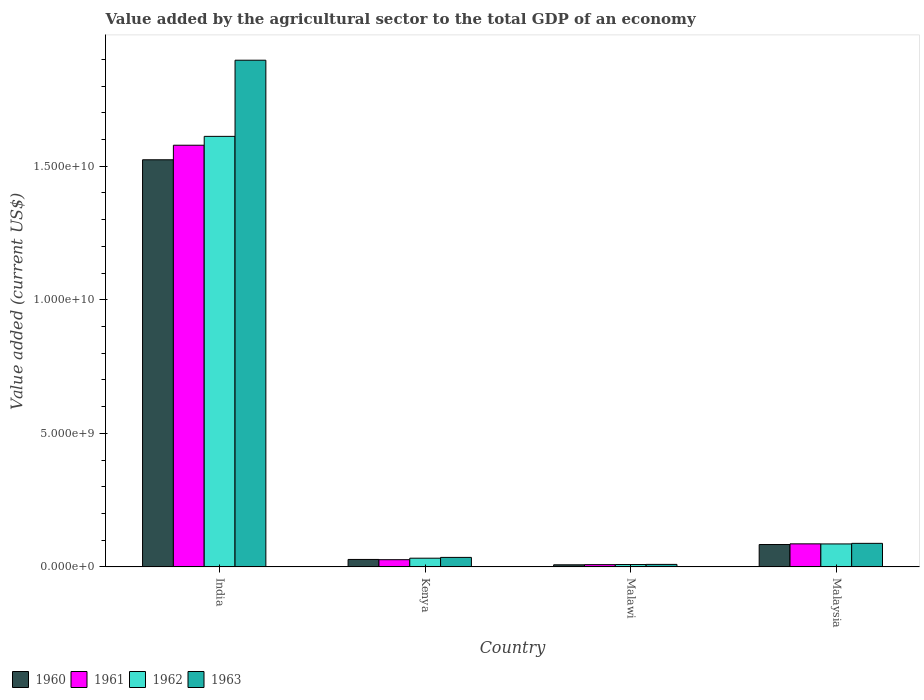Are the number of bars per tick equal to the number of legend labels?
Your answer should be very brief. Yes. Are the number of bars on each tick of the X-axis equal?
Offer a very short reply. Yes. How many bars are there on the 1st tick from the left?
Give a very brief answer. 4. How many bars are there on the 4th tick from the right?
Keep it short and to the point. 4. In how many cases, is the number of bars for a given country not equal to the number of legend labels?
Your answer should be compact. 0. What is the value added by the agricultural sector to the total GDP in 1963 in Malaysia?
Make the answer very short. 8.82e+08. Across all countries, what is the maximum value added by the agricultural sector to the total GDP in 1963?
Make the answer very short. 1.90e+1. Across all countries, what is the minimum value added by the agricultural sector to the total GDP in 1962?
Make the answer very short. 8.90e+07. In which country was the value added by the agricultural sector to the total GDP in 1960 minimum?
Offer a very short reply. Malawi. What is the total value added by the agricultural sector to the total GDP in 1963 in the graph?
Ensure brevity in your answer.  2.03e+1. What is the difference between the value added by the agricultural sector to the total GDP in 1960 in India and that in Malaysia?
Give a very brief answer. 1.44e+1. What is the difference between the value added by the agricultural sector to the total GDP in 1963 in Malaysia and the value added by the agricultural sector to the total GDP in 1962 in Malawi?
Your answer should be compact. 7.93e+08. What is the average value added by the agricultural sector to the total GDP in 1961 per country?
Offer a terse response. 4.25e+09. What is the difference between the value added by the agricultural sector to the total GDP of/in 1963 and value added by the agricultural sector to the total GDP of/in 1962 in India?
Your answer should be very brief. 2.85e+09. What is the ratio of the value added by the agricultural sector to the total GDP in 1962 in India to that in Malawi?
Provide a succinct answer. 180.99. Is the value added by the agricultural sector to the total GDP in 1963 in India less than that in Kenya?
Provide a short and direct response. No. What is the difference between the highest and the second highest value added by the agricultural sector to the total GDP in 1960?
Give a very brief answer. -5.58e+08. What is the difference between the highest and the lowest value added by the agricultural sector to the total GDP in 1962?
Your answer should be very brief. 1.60e+1. Is it the case that in every country, the sum of the value added by the agricultural sector to the total GDP in 1961 and value added by the agricultural sector to the total GDP in 1960 is greater than the sum of value added by the agricultural sector to the total GDP in 1963 and value added by the agricultural sector to the total GDP in 1962?
Give a very brief answer. No. What does the 1st bar from the left in Kenya represents?
Offer a very short reply. 1960. What does the 4th bar from the right in Kenya represents?
Ensure brevity in your answer.  1960. How many bars are there?
Your answer should be compact. 16. Are all the bars in the graph horizontal?
Provide a short and direct response. No. How many countries are there in the graph?
Give a very brief answer. 4. Does the graph contain any zero values?
Offer a very short reply. No. Does the graph contain grids?
Provide a succinct answer. No. Where does the legend appear in the graph?
Provide a succinct answer. Bottom left. How are the legend labels stacked?
Your answer should be compact. Horizontal. What is the title of the graph?
Make the answer very short. Value added by the agricultural sector to the total GDP of an economy. Does "1997" appear as one of the legend labels in the graph?
Ensure brevity in your answer.  No. What is the label or title of the X-axis?
Keep it short and to the point. Country. What is the label or title of the Y-axis?
Give a very brief answer. Value added (current US$). What is the Value added (current US$) in 1960 in India?
Provide a short and direct response. 1.52e+1. What is the Value added (current US$) in 1961 in India?
Your answer should be compact. 1.58e+1. What is the Value added (current US$) of 1962 in India?
Offer a very short reply. 1.61e+1. What is the Value added (current US$) of 1963 in India?
Make the answer very short. 1.90e+1. What is the Value added (current US$) of 1960 in Kenya?
Provide a succinct answer. 2.80e+08. What is the Value added (current US$) of 1961 in Kenya?
Offer a terse response. 2.70e+08. What is the Value added (current US$) of 1962 in Kenya?
Keep it short and to the point. 3.26e+08. What is the Value added (current US$) of 1963 in Kenya?
Ensure brevity in your answer.  3.56e+08. What is the Value added (current US$) in 1960 in Malawi?
Make the answer very short. 7.88e+07. What is the Value added (current US$) of 1961 in Malawi?
Provide a short and direct response. 8.48e+07. What is the Value added (current US$) of 1962 in Malawi?
Make the answer very short. 8.90e+07. What is the Value added (current US$) in 1963 in Malawi?
Provide a succinct answer. 9.39e+07. What is the Value added (current US$) of 1960 in Malaysia?
Give a very brief answer. 8.38e+08. What is the Value added (current US$) in 1961 in Malaysia?
Your response must be concise. 8.63e+08. What is the Value added (current US$) of 1962 in Malaysia?
Your response must be concise. 8.60e+08. What is the Value added (current US$) of 1963 in Malaysia?
Provide a short and direct response. 8.82e+08. Across all countries, what is the maximum Value added (current US$) of 1960?
Make the answer very short. 1.52e+1. Across all countries, what is the maximum Value added (current US$) in 1961?
Provide a short and direct response. 1.58e+1. Across all countries, what is the maximum Value added (current US$) of 1962?
Keep it short and to the point. 1.61e+1. Across all countries, what is the maximum Value added (current US$) in 1963?
Your response must be concise. 1.90e+1. Across all countries, what is the minimum Value added (current US$) in 1960?
Provide a short and direct response. 7.88e+07. Across all countries, what is the minimum Value added (current US$) of 1961?
Your response must be concise. 8.48e+07. Across all countries, what is the minimum Value added (current US$) in 1962?
Ensure brevity in your answer.  8.90e+07. Across all countries, what is the minimum Value added (current US$) of 1963?
Provide a short and direct response. 9.39e+07. What is the total Value added (current US$) of 1960 in the graph?
Offer a very short reply. 1.64e+1. What is the total Value added (current US$) of 1961 in the graph?
Offer a terse response. 1.70e+1. What is the total Value added (current US$) in 1962 in the graph?
Give a very brief answer. 1.74e+1. What is the total Value added (current US$) of 1963 in the graph?
Keep it short and to the point. 2.03e+1. What is the difference between the Value added (current US$) of 1960 in India and that in Kenya?
Your response must be concise. 1.50e+1. What is the difference between the Value added (current US$) in 1961 in India and that in Kenya?
Ensure brevity in your answer.  1.55e+1. What is the difference between the Value added (current US$) of 1962 in India and that in Kenya?
Offer a very short reply. 1.58e+1. What is the difference between the Value added (current US$) in 1963 in India and that in Kenya?
Your response must be concise. 1.86e+1. What is the difference between the Value added (current US$) in 1960 in India and that in Malawi?
Ensure brevity in your answer.  1.52e+1. What is the difference between the Value added (current US$) of 1961 in India and that in Malawi?
Give a very brief answer. 1.57e+1. What is the difference between the Value added (current US$) in 1962 in India and that in Malawi?
Your answer should be compact. 1.60e+1. What is the difference between the Value added (current US$) in 1963 in India and that in Malawi?
Your answer should be compact. 1.89e+1. What is the difference between the Value added (current US$) in 1960 in India and that in Malaysia?
Your answer should be compact. 1.44e+1. What is the difference between the Value added (current US$) in 1961 in India and that in Malaysia?
Your response must be concise. 1.49e+1. What is the difference between the Value added (current US$) of 1962 in India and that in Malaysia?
Keep it short and to the point. 1.53e+1. What is the difference between the Value added (current US$) of 1963 in India and that in Malaysia?
Keep it short and to the point. 1.81e+1. What is the difference between the Value added (current US$) of 1960 in Kenya and that in Malawi?
Keep it short and to the point. 2.01e+08. What is the difference between the Value added (current US$) of 1961 in Kenya and that in Malawi?
Your response must be concise. 1.85e+08. What is the difference between the Value added (current US$) in 1962 in Kenya and that in Malawi?
Your answer should be very brief. 2.37e+08. What is the difference between the Value added (current US$) in 1963 in Kenya and that in Malawi?
Your answer should be compact. 2.62e+08. What is the difference between the Value added (current US$) in 1960 in Kenya and that in Malaysia?
Provide a succinct answer. -5.58e+08. What is the difference between the Value added (current US$) of 1961 in Kenya and that in Malaysia?
Your response must be concise. -5.93e+08. What is the difference between the Value added (current US$) of 1962 in Kenya and that in Malaysia?
Keep it short and to the point. -5.34e+08. What is the difference between the Value added (current US$) in 1963 in Kenya and that in Malaysia?
Your answer should be compact. -5.25e+08. What is the difference between the Value added (current US$) of 1960 in Malawi and that in Malaysia?
Make the answer very short. -7.59e+08. What is the difference between the Value added (current US$) of 1961 in Malawi and that in Malaysia?
Give a very brief answer. -7.78e+08. What is the difference between the Value added (current US$) of 1962 in Malawi and that in Malaysia?
Offer a terse response. -7.71e+08. What is the difference between the Value added (current US$) in 1963 in Malawi and that in Malaysia?
Provide a succinct answer. -7.88e+08. What is the difference between the Value added (current US$) in 1960 in India and the Value added (current US$) in 1961 in Kenya?
Give a very brief answer. 1.50e+1. What is the difference between the Value added (current US$) of 1960 in India and the Value added (current US$) of 1962 in Kenya?
Your response must be concise. 1.49e+1. What is the difference between the Value added (current US$) in 1960 in India and the Value added (current US$) in 1963 in Kenya?
Offer a terse response. 1.49e+1. What is the difference between the Value added (current US$) in 1961 in India and the Value added (current US$) in 1962 in Kenya?
Offer a terse response. 1.55e+1. What is the difference between the Value added (current US$) in 1961 in India and the Value added (current US$) in 1963 in Kenya?
Make the answer very short. 1.54e+1. What is the difference between the Value added (current US$) in 1962 in India and the Value added (current US$) in 1963 in Kenya?
Offer a terse response. 1.58e+1. What is the difference between the Value added (current US$) of 1960 in India and the Value added (current US$) of 1961 in Malawi?
Provide a succinct answer. 1.52e+1. What is the difference between the Value added (current US$) in 1960 in India and the Value added (current US$) in 1962 in Malawi?
Your answer should be compact. 1.51e+1. What is the difference between the Value added (current US$) in 1960 in India and the Value added (current US$) in 1963 in Malawi?
Offer a very short reply. 1.51e+1. What is the difference between the Value added (current US$) in 1961 in India and the Value added (current US$) in 1962 in Malawi?
Your answer should be very brief. 1.57e+1. What is the difference between the Value added (current US$) in 1961 in India and the Value added (current US$) in 1963 in Malawi?
Offer a terse response. 1.57e+1. What is the difference between the Value added (current US$) of 1962 in India and the Value added (current US$) of 1963 in Malawi?
Ensure brevity in your answer.  1.60e+1. What is the difference between the Value added (current US$) of 1960 in India and the Value added (current US$) of 1961 in Malaysia?
Your answer should be very brief. 1.44e+1. What is the difference between the Value added (current US$) of 1960 in India and the Value added (current US$) of 1962 in Malaysia?
Your answer should be compact. 1.44e+1. What is the difference between the Value added (current US$) in 1960 in India and the Value added (current US$) in 1963 in Malaysia?
Offer a very short reply. 1.44e+1. What is the difference between the Value added (current US$) of 1961 in India and the Value added (current US$) of 1962 in Malaysia?
Your response must be concise. 1.49e+1. What is the difference between the Value added (current US$) in 1961 in India and the Value added (current US$) in 1963 in Malaysia?
Make the answer very short. 1.49e+1. What is the difference between the Value added (current US$) in 1962 in India and the Value added (current US$) in 1963 in Malaysia?
Your response must be concise. 1.52e+1. What is the difference between the Value added (current US$) of 1960 in Kenya and the Value added (current US$) of 1961 in Malawi?
Keep it short and to the point. 1.95e+08. What is the difference between the Value added (current US$) of 1960 in Kenya and the Value added (current US$) of 1962 in Malawi?
Your answer should be very brief. 1.91e+08. What is the difference between the Value added (current US$) in 1960 in Kenya and the Value added (current US$) in 1963 in Malawi?
Ensure brevity in your answer.  1.86e+08. What is the difference between the Value added (current US$) in 1961 in Kenya and the Value added (current US$) in 1962 in Malawi?
Ensure brevity in your answer.  1.81e+08. What is the difference between the Value added (current US$) of 1961 in Kenya and the Value added (current US$) of 1963 in Malawi?
Provide a short and direct response. 1.76e+08. What is the difference between the Value added (current US$) in 1962 in Kenya and the Value added (current US$) in 1963 in Malawi?
Offer a very short reply. 2.32e+08. What is the difference between the Value added (current US$) in 1960 in Kenya and the Value added (current US$) in 1961 in Malaysia?
Keep it short and to the point. -5.83e+08. What is the difference between the Value added (current US$) of 1960 in Kenya and the Value added (current US$) of 1962 in Malaysia?
Provide a short and direct response. -5.80e+08. What is the difference between the Value added (current US$) of 1960 in Kenya and the Value added (current US$) of 1963 in Malaysia?
Give a very brief answer. -6.02e+08. What is the difference between the Value added (current US$) of 1961 in Kenya and the Value added (current US$) of 1962 in Malaysia?
Provide a short and direct response. -5.90e+08. What is the difference between the Value added (current US$) of 1961 in Kenya and the Value added (current US$) of 1963 in Malaysia?
Ensure brevity in your answer.  -6.11e+08. What is the difference between the Value added (current US$) of 1962 in Kenya and the Value added (current US$) of 1963 in Malaysia?
Offer a terse response. -5.55e+08. What is the difference between the Value added (current US$) in 1960 in Malawi and the Value added (current US$) in 1961 in Malaysia?
Your answer should be compact. -7.84e+08. What is the difference between the Value added (current US$) in 1960 in Malawi and the Value added (current US$) in 1962 in Malaysia?
Offer a terse response. -7.81e+08. What is the difference between the Value added (current US$) of 1960 in Malawi and the Value added (current US$) of 1963 in Malaysia?
Keep it short and to the point. -8.03e+08. What is the difference between the Value added (current US$) of 1961 in Malawi and the Value added (current US$) of 1962 in Malaysia?
Offer a very short reply. -7.75e+08. What is the difference between the Value added (current US$) of 1961 in Malawi and the Value added (current US$) of 1963 in Malaysia?
Make the answer very short. -7.97e+08. What is the difference between the Value added (current US$) of 1962 in Malawi and the Value added (current US$) of 1963 in Malaysia?
Give a very brief answer. -7.93e+08. What is the average Value added (current US$) in 1960 per country?
Offer a terse response. 4.11e+09. What is the average Value added (current US$) of 1961 per country?
Offer a terse response. 4.25e+09. What is the average Value added (current US$) of 1962 per country?
Provide a succinct answer. 4.35e+09. What is the average Value added (current US$) in 1963 per country?
Give a very brief answer. 5.07e+09. What is the difference between the Value added (current US$) in 1960 and Value added (current US$) in 1961 in India?
Keep it short and to the point. -5.45e+08. What is the difference between the Value added (current US$) of 1960 and Value added (current US$) of 1962 in India?
Offer a very short reply. -8.76e+08. What is the difference between the Value added (current US$) of 1960 and Value added (current US$) of 1963 in India?
Your answer should be compact. -3.73e+09. What is the difference between the Value added (current US$) in 1961 and Value added (current US$) in 1962 in India?
Your answer should be compact. -3.32e+08. What is the difference between the Value added (current US$) in 1961 and Value added (current US$) in 1963 in India?
Offer a terse response. -3.18e+09. What is the difference between the Value added (current US$) in 1962 and Value added (current US$) in 1963 in India?
Provide a succinct answer. -2.85e+09. What is the difference between the Value added (current US$) of 1960 and Value added (current US$) of 1961 in Kenya?
Make the answer very short. 9.51e+06. What is the difference between the Value added (current US$) of 1960 and Value added (current US$) of 1962 in Kenya?
Give a very brief answer. -4.65e+07. What is the difference between the Value added (current US$) in 1960 and Value added (current US$) in 1963 in Kenya?
Keep it short and to the point. -7.66e+07. What is the difference between the Value added (current US$) of 1961 and Value added (current US$) of 1962 in Kenya?
Your answer should be very brief. -5.60e+07. What is the difference between the Value added (current US$) in 1961 and Value added (current US$) in 1963 in Kenya?
Your response must be concise. -8.61e+07. What is the difference between the Value added (current US$) in 1962 and Value added (current US$) in 1963 in Kenya?
Your response must be concise. -3.01e+07. What is the difference between the Value added (current US$) in 1960 and Value added (current US$) in 1961 in Malawi?
Provide a succinct answer. -6.02e+06. What is the difference between the Value added (current US$) in 1960 and Value added (current US$) in 1962 in Malawi?
Make the answer very short. -1.02e+07. What is the difference between the Value added (current US$) in 1960 and Value added (current US$) in 1963 in Malawi?
Keep it short and to the point. -1.51e+07. What is the difference between the Value added (current US$) of 1961 and Value added (current US$) of 1962 in Malawi?
Keep it short and to the point. -4.20e+06. What is the difference between the Value added (current US$) in 1961 and Value added (current US$) in 1963 in Malawi?
Your response must be concise. -9.10e+06. What is the difference between the Value added (current US$) of 1962 and Value added (current US$) of 1963 in Malawi?
Keep it short and to the point. -4.90e+06. What is the difference between the Value added (current US$) of 1960 and Value added (current US$) of 1961 in Malaysia?
Give a very brief answer. -2.54e+07. What is the difference between the Value added (current US$) in 1960 and Value added (current US$) in 1962 in Malaysia?
Provide a short and direct response. -2.23e+07. What is the difference between the Value added (current US$) in 1960 and Value added (current US$) in 1963 in Malaysia?
Provide a succinct answer. -4.39e+07. What is the difference between the Value added (current US$) of 1961 and Value added (current US$) of 1962 in Malaysia?
Offer a terse response. 3.09e+06. What is the difference between the Value added (current US$) of 1961 and Value added (current US$) of 1963 in Malaysia?
Your answer should be compact. -1.85e+07. What is the difference between the Value added (current US$) in 1962 and Value added (current US$) in 1963 in Malaysia?
Provide a short and direct response. -2.16e+07. What is the ratio of the Value added (current US$) of 1960 in India to that in Kenya?
Your answer should be compact. 54.48. What is the ratio of the Value added (current US$) in 1961 in India to that in Kenya?
Provide a short and direct response. 58.42. What is the ratio of the Value added (current US$) of 1962 in India to that in Kenya?
Offer a terse response. 49.4. What is the ratio of the Value added (current US$) of 1963 in India to that in Kenya?
Keep it short and to the point. 53.23. What is the ratio of the Value added (current US$) in 1960 in India to that in Malawi?
Ensure brevity in your answer.  193.33. What is the ratio of the Value added (current US$) in 1961 in India to that in Malawi?
Keep it short and to the point. 186.04. What is the ratio of the Value added (current US$) of 1962 in India to that in Malawi?
Ensure brevity in your answer.  180.99. What is the ratio of the Value added (current US$) of 1963 in India to that in Malawi?
Offer a terse response. 201.89. What is the ratio of the Value added (current US$) of 1960 in India to that in Malaysia?
Provide a succinct answer. 18.19. What is the ratio of the Value added (current US$) in 1961 in India to that in Malaysia?
Provide a short and direct response. 18.29. What is the ratio of the Value added (current US$) of 1962 in India to that in Malaysia?
Provide a succinct answer. 18.74. What is the ratio of the Value added (current US$) in 1963 in India to that in Malaysia?
Provide a succinct answer. 21.51. What is the ratio of the Value added (current US$) in 1960 in Kenya to that in Malawi?
Provide a short and direct response. 3.55. What is the ratio of the Value added (current US$) in 1961 in Kenya to that in Malawi?
Your answer should be very brief. 3.18. What is the ratio of the Value added (current US$) in 1962 in Kenya to that in Malawi?
Keep it short and to the point. 3.66. What is the ratio of the Value added (current US$) of 1963 in Kenya to that in Malawi?
Provide a short and direct response. 3.79. What is the ratio of the Value added (current US$) in 1960 in Kenya to that in Malaysia?
Make the answer very short. 0.33. What is the ratio of the Value added (current US$) in 1961 in Kenya to that in Malaysia?
Ensure brevity in your answer.  0.31. What is the ratio of the Value added (current US$) in 1962 in Kenya to that in Malaysia?
Your answer should be compact. 0.38. What is the ratio of the Value added (current US$) of 1963 in Kenya to that in Malaysia?
Give a very brief answer. 0.4. What is the ratio of the Value added (current US$) in 1960 in Malawi to that in Malaysia?
Offer a very short reply. 0.09. What is the ratio of the Value added (current US$) of 1961 in Malawi to that in Malaysia?
Your response must be concise. 0.1. What is the ratio of the Value added (current US$) of 1962 in Malawi to that in Malaysia?
Provide a short and direct response. 0.1. What is the ratio of the Value added (current US$) in 1963 in Malawi to that in Malaysia?
Offer a very short reply. 0.11. What is the difference between the highest and the second highest Value added (current US$) in 1960?
Your answer should be very brief. 1.44e+1. What is the difference between the highest and the second highest Value added (current US$) in 1961?
Offer a very short reply. 1.49e+1. What is the difference between the highest and the second highest Value added (current US$) in 1962?
Provide a succinct answer. 1.53e+1. What is the difference between the highest and the second highest Value added (current US$) of 1963?
Your answer should be compact. 1.81e+1. What is the difference between the highest and the lowest Value added (current US$) in 1960?
Provide a succinct answer. 1.52e+1. What is the difference between the highest and the lowest Value added (current US$) of 1961?
Offer a very short reply. 1.57e+1. What is the difference between the highest and the lowest Value added (current US$) in 1962?
Make the answer very short. 1.60e+1. What is the difference between the highest and the lowest Value added (current US$) of 1963?
Make the answer very short. 1.89e+1. 